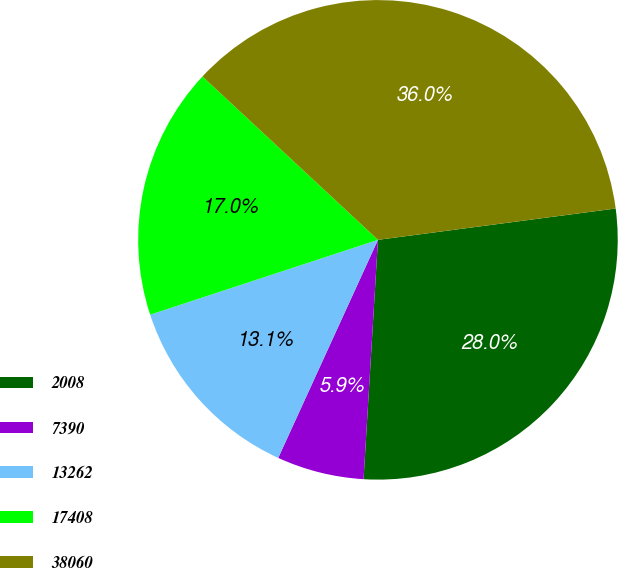<chart> <loc_0><loc_0><loc_500><loc_500><pie_chart><fcel>2008<fcel>7390<fcel>13262<fcel>17408<fcel>38060<nl><fcel>28.04%<fcel>5.87%<fcel>13.12%<fcel>16.98%<fcel>35.98%<nl></chart> 